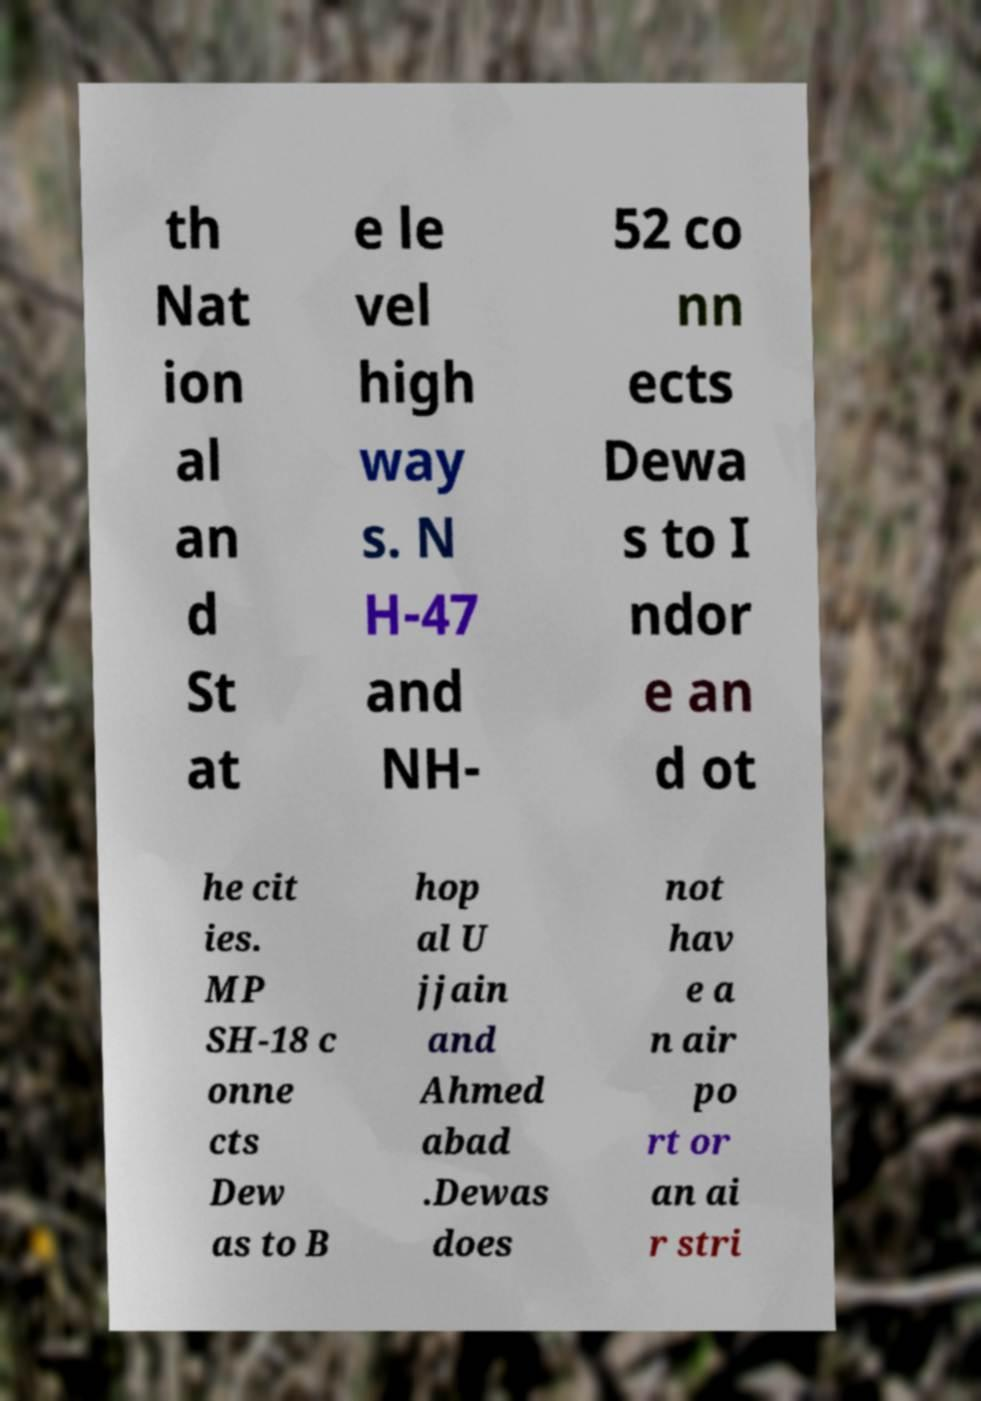Could you assist in decoding the text presented in this image and type it out clearly? th Nat ion al an d St at e le vel high way s. N H-47 and NH- 52 co nn ects Dewa s to I ndor e an d ot he cit ies. MP SH-18 c onne cts Dew as to B hop al U jjain and Ahmed abad .Dewas does not hav e a n air po rt or an ai r stri 